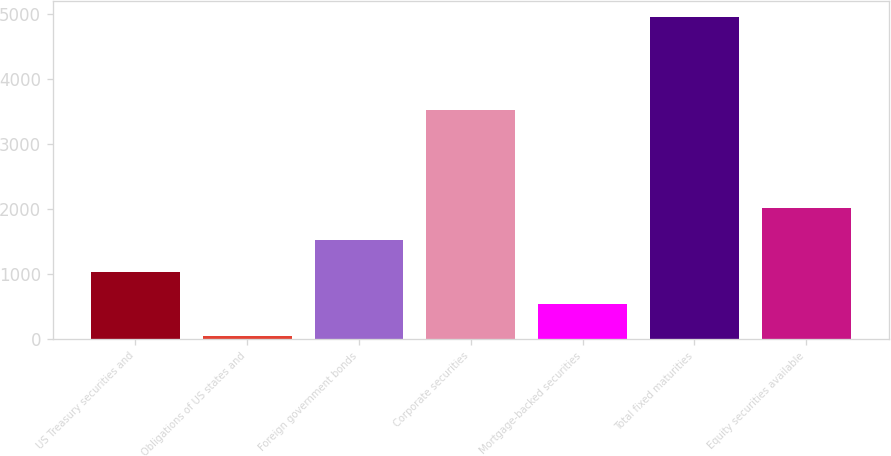<chart> <loc_0><loc_0><loc_500><loc_500><bar_chart><fcel>US Treasury securities and<fcel>Obligations of US states and<fcel>Foreign government bonds<fcel>Corporate securities<fcel>Mortgage-backed securities<fcel>Total fixed maturities<fcel>Equity securities available<nl><fcel>1032.4<fcel>52<fcel>1522.6<fcel>3523<fcel>542.2<fcel>4954<fcel>2012.8<nl></chart> 